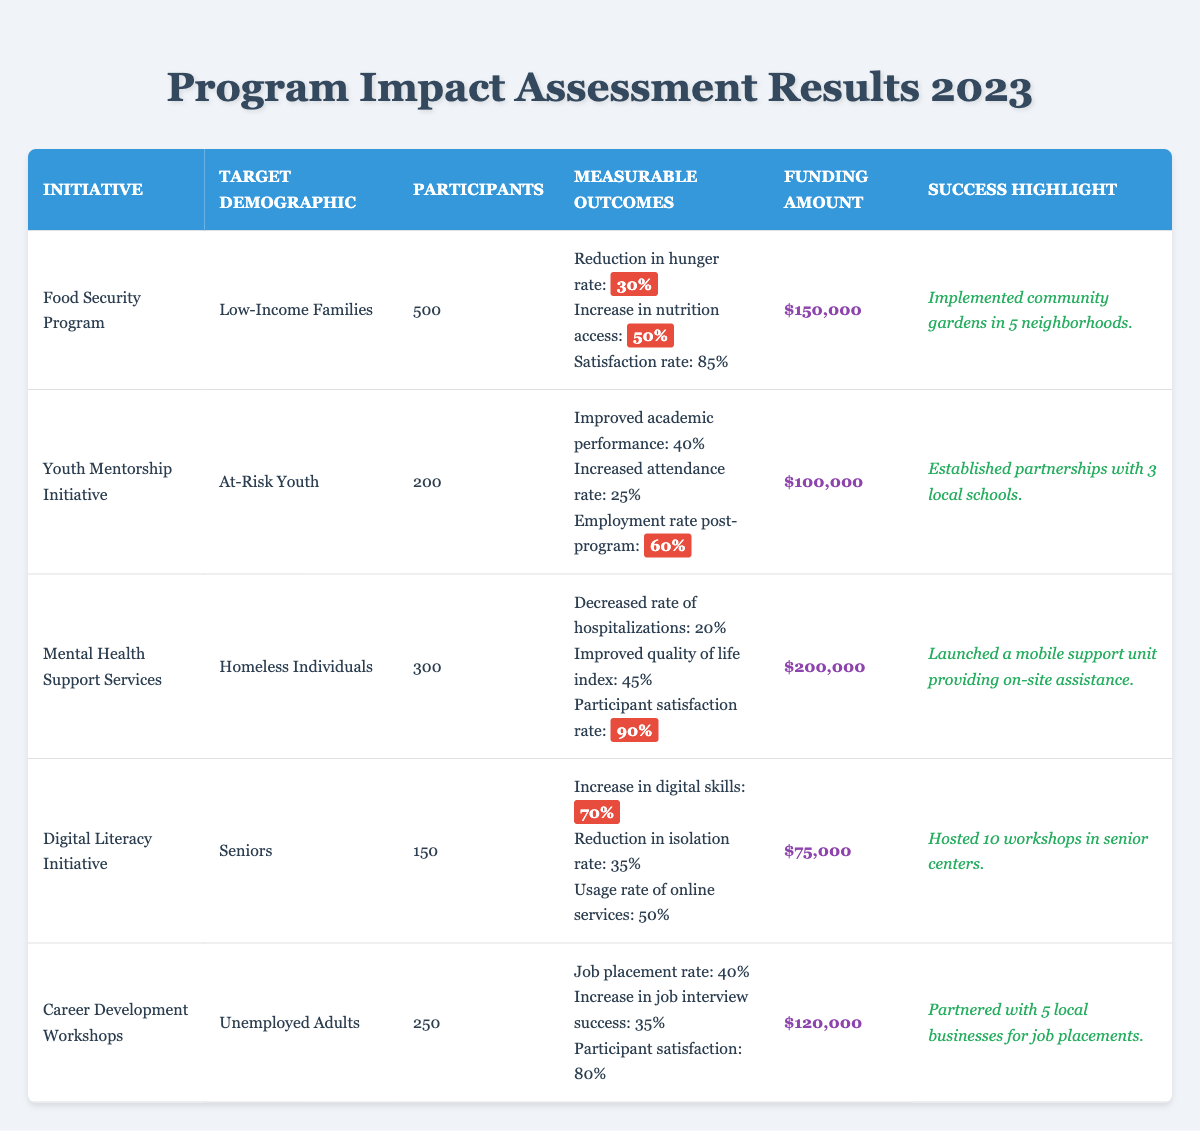What is the funding amount for the Food Security Program? The table lists the funding amounts for each initiative. For the Food Security Program, it shows $150,000.
Answer: $150,000 How many participants were involved in the Mental Health Support Services initiative? The number of participants is specifically mentioned in the table for each initiative. The Mental Health Support Services had 300 participants.
Answer: 300 What percentage increase in access to nutrition was reported in the Food Security Program? The measurable outcome for the Food Security Program mentions a 50% increase in nutrition access.
Answer: 50% Is the participant satisfaction rate for the Digital Literacy Initiative higher than 80%? The participant satisfaction for Digital Literacy Initiative is not explicitly stated in the table, but the other relevant initiatives listed have their satisfaction rates shown. Comparing it directly, Digital Literacy's satisfaction isn't noted, so we cannot confirm if it's higher than 80%.
Answer: Cannot determine What is the total number of participants across all initiatives? To find the total, sum the participants from all initiatives listed in the table: 500 (Food Security) + 200 (Youth Mentorship) + 300 (Mental Health) + 150 (Digital Literacy) + 250 (Career Development) = 1,400 participants.
Answer: 1,400 Which initiative had the highest participant satisfaction rate? The table lists participant satisfaction rates for various initiatives. The Mental Health Support Services has a satisfaction rate of 90%, which is the highest among the initiatives.
Answer: Mental Health Support Services How much was the funding amount for the Youth Mentorship Initiative compared to the Digital Literacy Initiative? The funding amounts for both initiatives are in the table: Youth Mentorship Initiative is $100,000, and Digital Literacy Initiative is $75,000. To compare them, $100,000 is greater than $75,000. Therefore, Youth Mentorship received more funding.
Answer: Youth Mentorship Initiative What is the success highlight for the Career Development Workshops? Each initiative has a success highlight listed in the table. For Career Development Workshops, the success highlight is partnering with 5 local businesses for job placements.
Answer: Partnered with 5 local businesses for job placements Was the rate of improvement in academic performance for at-risk youth lower than the employment rate post-program? The table shows a 40% improvement in academic performance and a 60% employment rate post-program. Since 40% is lower than 60%, the statement is true.
Answer: Yes 